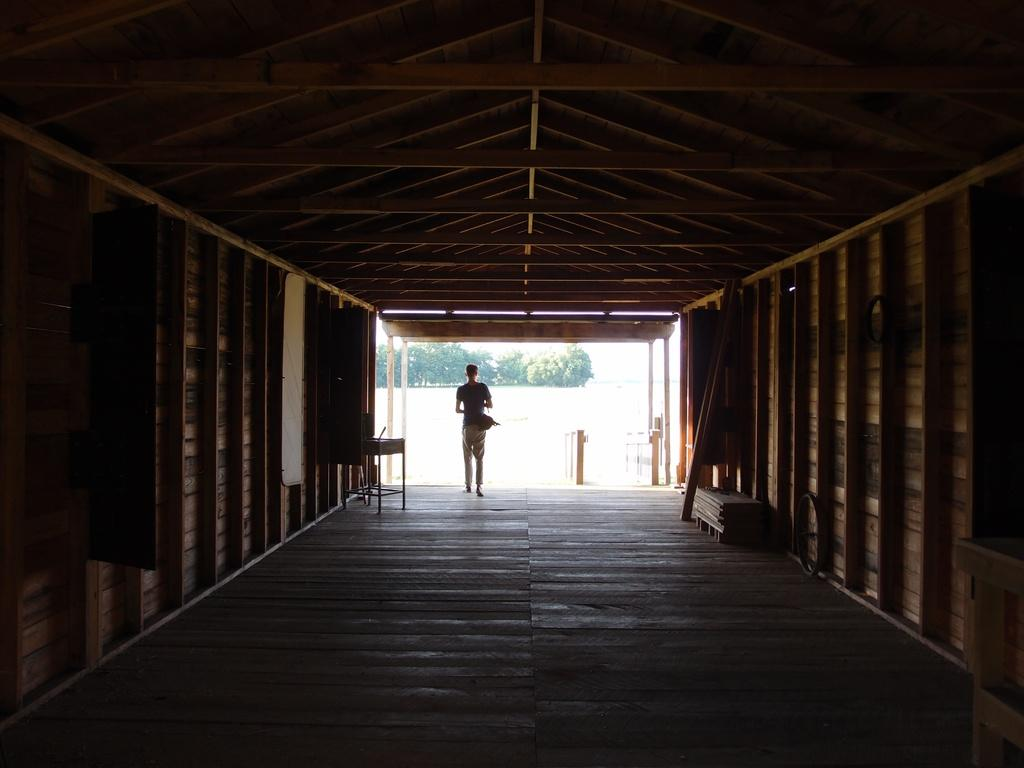What is the main subject in the image? There is a tunnel in the image. What else can be seen in the image besides the tunnel? There are objects and a person in the image. What is visible in the background of the image? There are trees in the background of the image, and the background appears to be white. What type of banana is being served on the tray in the image? There is no banana or tray present in the image. What is the person in the image doing with the pot? There is no pot or activity involving a pot in the image. 